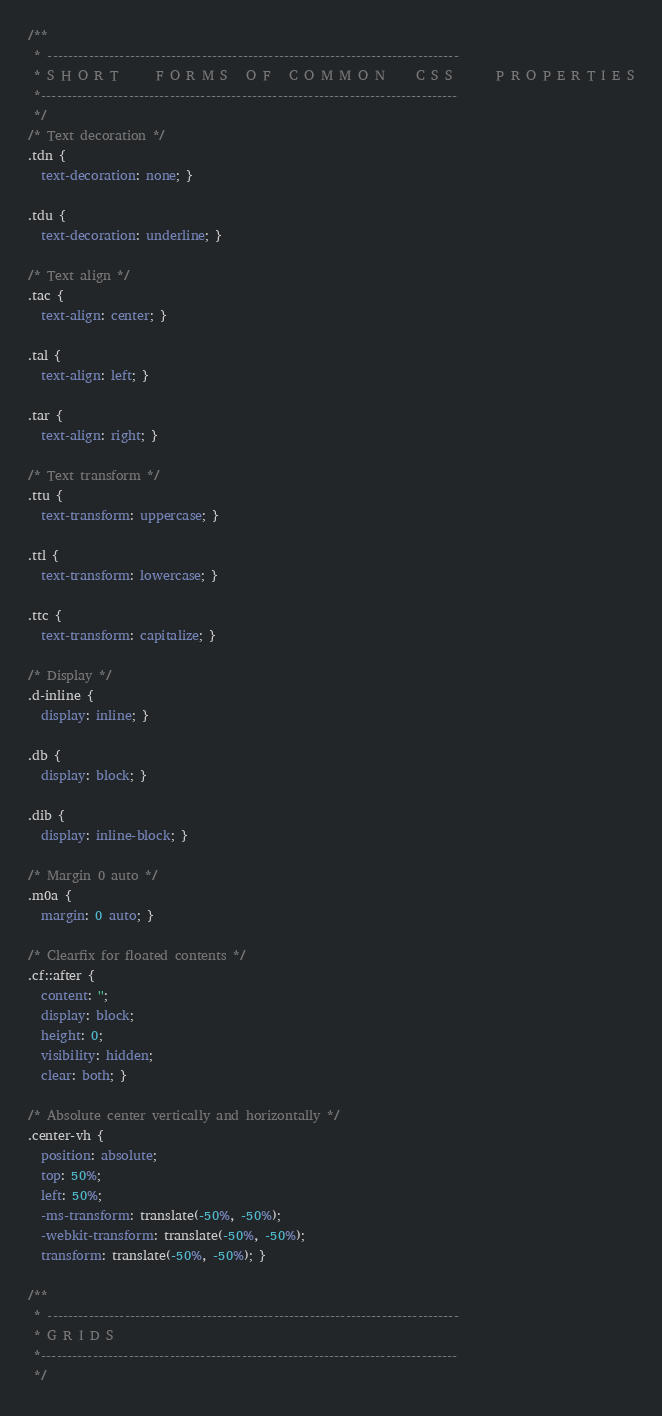Convert code to text. <code><loc_0><loc_0><loc_500><loc_500><_CSS_>/**
 * --------------------------------------------------------------------------------
 * S H O R T      F O R M S   O F   C O M M O N     C S S       P R O P E R T I E S
 *---------------------------------------------------------------------------------
 */
/* Text decoration */
.tdn {
  text-decoration: none; }

.tdu {
  text-decoration: underline; }

/* Text align */
.tac {
  text-align: center; }

.tal {
  text-align: left; }

.tar {
  text-align: right; }

/* Text transform */
.ttu {
  text-transform: uppercase; }

.ttl {
  text-transform: lowercase; }

.ttc {
  text-transform: capitalize; }

/* Display */
.d-inline {
  display: inline; }

.db {
  display: block; }

.dib {
  display: inline-block; }

/* Margin 0 auto */
.m0a {
  margin: 0 auto; }

/* Clearfix for floated contents */
.cf::after {
  content: '';
  display: block;
  height: 0;
  visibility: hidden;
  clear: both; }

/* Absolute center vertically and horizontally */
.center-vh {
  position: absolute;
  top: 50%;
  left: 50%;
  -ms-transform: translate(-50%, -50%);
  -webkit-transform: translate(-50%, -50%);
  transform: translate(-50%, -50%); }

/**
 * --------------------------------------------------------------------------------
 * G R I D S
 *---------------------------------------------------------------------------------
 */
</code> 